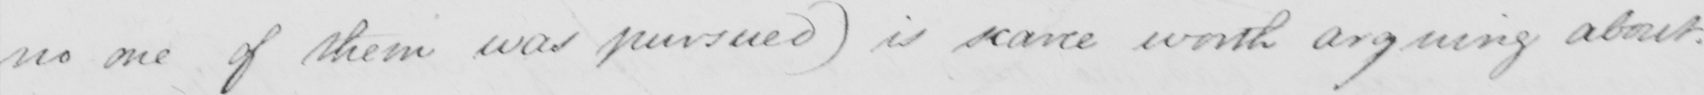What is written in this line of handwriting? no one of them was pursued) is scarce worth arguing about. 